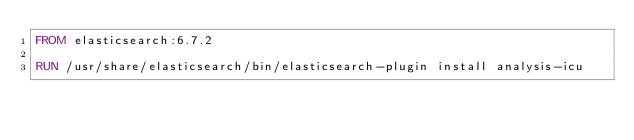<code> <loc_0><loc_0><loc_500><loc_500><_Dockerfile_>FROM elasticsearch:6.7.2

RUN /usr/share/elasticsearch/bin/elasticsearch-plugin install analysis-icu
</code> 